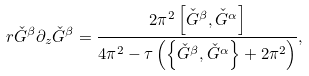Convert formula to latex. <formula><loc_0><loc_0><loc_500><loc_500>r { \check { G } } ^ { \beta } \partial _ { z } { \check { G } } ^ { \beta } = \frac { 2 \pi ^ { 2 } \left [ { \check { G } } ^ { \beta } , { \check { G } } ^ { \alpha } \right ] } { 4 \pi ^ { 2 } - \tau \left ( \left \{ { \check { G } } ^ { \beta } , { \check { G } } ^ { \alpha } \right \} + 2 \pi ^ { 2 } \right ) } ,</formula> 